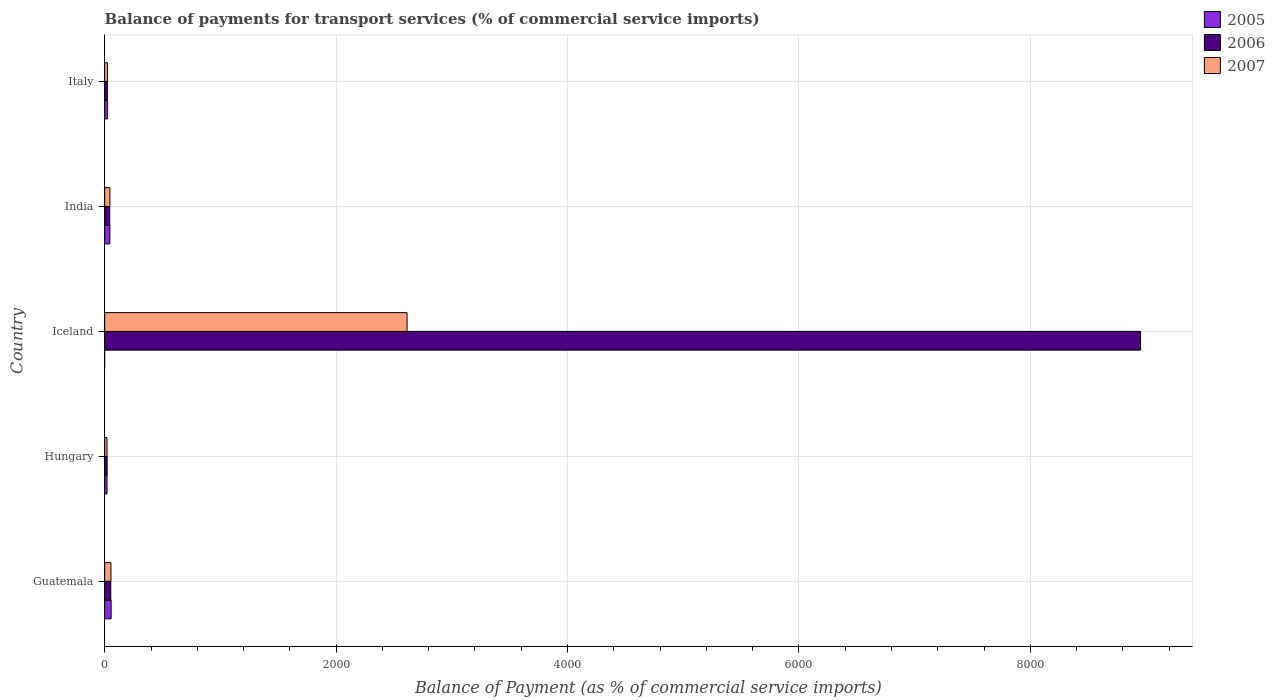How many different coloured bars are there?
Your answer should be compact. 3. Are the number of bars on each tick of the Y-axis equal?
Ensure brevity in your answer.  No. How many bars are there on the 5th tick from the bottom?
Give a very brief answer. 3. In how many cases, is the number of bars for a given country not equal to the number of legend labels?
Give a very brief answer. 1. What is the balance of payments for transport services in 2007 in Italy?
Provide a short and direct response. 23.34. Across all countries, what is the maximum balance of payments for transport services in 2006?
Offer a very short reply. 8952.73. Across all countries, what is the minimum balance of payments for transport services in 2006?
Your answer should be compact. 21.15. What is the total balance of payments for transport services in 2006 in the graph?
Provide a short and direct response. 9093.1. What is the difference between the balance of payments for transport services in 2006 in India and that in Italy?
Make the answer very short. 19.88. What is the difference between the balance of payments for transport services in 2006 in Guatemala and the balance of payments for transport services in 2005 in Iceland?
Provide a succinct answer. 52.41. What is the average balance of payments for transport services in 2006 per country?
Offer a very short reply. 1818.62. What is the difference between the balance of payments for transport services in 2007 and balance of payments for transport services in 2006 in India?
Your answer should be very brief. 1.48. What is the ratio of the balance of payments for transport services in 2006 in Iceland to that in India?
Keep it short and to the point. 206.53. What is the difference between the highest and the second highest balance of payments for transport services in 2005?
Keep it short and to the point. 10.79. What is the difference between the highest and the lowest balance of payments for transport services in 2007?
Your response must be concise. 2593.2. Is it the case that in every country, the sum of the balance of payments for transport services in 2006 and balance of payments for transport services in 2005 is greater than the balance of payments for transport services in 2007?
Provide a succinct answer. Yes. Are all the bars in the graph horizontal?
Your answer should be compact. Yes. How many countries are there in the graph?
Ensure brevity in your answer.  5. Where does the legend appear in the graph?
Provide a succinct answer. Top right. How are the legend labels stacked?
Provide a short and direct response. Vertical. What is the title of the graph?
Your response must be concise. Balance of payments for transport services (% of commercial service imports). Does "1997" appear as one of the legend labels in the graph?
Offer a very short reply. No. What is the label or title of the X-axis?
Ensure brevity in your answer.  Balance of Payment (as % of commercial service imports). What is the label or title of the Y-axis?
Your answer should be very brief. Country. What is the Balance of Payment (as % of commercial service imports) of 2005 in Guatemala?
Make the answer very short. 55.52. What is the Balance of Payment (as % of commercial service imports) in 2006 in Guatemala?
Keep it short and to the point. 52.41. What is the Balance of Payment (as % of commercial service imports) in 2007 in Guatemala?
Your answer should be very brief. 53.64. What is the Balance of Payment (as % of commercial service imports) in 2005 in Hungary?
Offer a terse response. 19.94. What is the Balance of Payment (as % of commercial service imports) of 2006 in Hungary?
Keep it short and to the point. 21.15. What is the Balance of Payment (as % of commercial service imports) in 2007 in Hungary?
Offer a terse response. 20.06. What is the Balance of Payment (as % of commercial service imports) of 2006 in Iceland?
Keep it short and to the point. 8952.73. What is the Balance of Payment (as % of commercial service imports) in 2007 in Iceland?
Your response must be concise. 2613.27. What is the Balance of Payment (as % of commercial service imports) of 2005 in India?
Keep it short and to the point. 44.73. What is the Balance of Payment (as % of commercial service imports) of 2006 in India?
Provide a short and direct response. 43.35. What is the Balance of Payment (as % of commercial service imports) in 2007 in India?
Ensure brevity in your answer.  44.82. What is the Balance of Payment (as % of commercial service imports) in 2005 in Italy?
Give a very brief answer. 24.75. What is the Balance of Payment (as % of commercial service imports) in 2006 in Italy?
Make the answer very short. 23.47. What is the Balance of Payment (as % of commercial service imports) of 2007 in Italy?
Make the answer very short. 23.34. Across all countries, what is the maximum Balance of Payment (as % of commercial service imports) of 2005?
Offer a terse response. 55.52. Across all countries, what is the maximum Balance of Payment (as % of commercial service imports) of 2006?
Keep it short and to the point. 8952.73. Across all countries, what is the maximum Balance of Payment (as % of commercial service imports) in 2007?
Your answer should be very brief. 2613.27. Across all countries, what is the minimum Balance of Payment (as % of commercial service imports) in 2006?
Your answer should be compact. 21.15. Across all countries, what is the minimum Balance of Payment (as % of commercial service imports) in 2007?
Provide a succinct answer. 20.06. What is the total Balance of Payment (as % of commercial service imports) of 2005 in the graph?
Provide a succinct answer. 144.93. What is the total Balance of Payment (as % of commercial service imports) of 2006 in the graph?
Keep it short and to the point. 9093.1. What is the total Balance of Payment (as % of commercial service imports) of 2007 in the graph?
Offer a very short reply. 2755.13. What is the difference between the Balance of Payment (as % of commercial service imports) of 2005 in Guatemala and that in Hungary?
Offer a terse response. 35.58. What is the difference between the Balance of Payment (as % of commercial service imports) of 2006 in Guatemala and that in Hungary?
Offer a very short reply. 31.26. What is the difference between the Balance of Payment (as % of commercial service imports) of 2007 in Guatemala and that in Hungary?
Ensure brevity in your answer.  33.58. What is the difference between the Balance of Payment (as % of commercial service imports) of 2006 in Guatemala and that in Iceland?
Offer a very short reply. -8900.32. What is the difference between the Balance of Payment (as % of commercial service imports) in 2007 in Guatemala and that in Iceland?
Provide a succinct answer. -2559.62. What is the difference between the Balance of Payment (as % of commercial service imports) in 2005 in Guatemala and that in India?
Offer a terse response. 10.79. What is the difference between the Balance of Payment (as % of commercial service imports) of 2006 in Guatemala and that in India?
Give a very brief answer. 9.06. What is the difference between the Balance of Payment (as % of commercial service imports) in 2007 in Guatemala and that in India?
Make the answer very short. 8.82. What is the difference between the Balance of Payment (as % of commercial service imports) of 2005 in Guatemala and that in Italy?
Ensure brevity in your answer.  30.77. What is the difference between the Balance of Payment (as % of commercial service imports) in 2006 in Guatemala and that in Italy?
Ensure brevity in your answer.  28.94. What is the difference between the Balance of Payment (as % of commercial service imports) in 2007 in Guatemala and that in Italy?
Make the answer very short. 30.31. What is the difference between the Balance of Payment (as % of commercial service imports) of 2006 in Hungary and that in Iceland?
Offer a terse response. -8931.58. What is the difference between the Balance of Payment (as % of commercial service imports) in 2007 in Hungary and that in Iceland?
Keep it short and to the point. -2593.2. What is the difference between the Balance of Payment (as % of commercial service imports) in 2005 in Hungary and that in India?
Your response must be concise. -24.79. What is the difference between the Balance of Payment (as % of commercial service imports) in 2006 in Hungary and that in India?
Provide a succinct answer. -22.2. What is the difference between the Balance of Payment (as % of commercial service imports) in 2007 in Hungary and that in India?
Ensure brevity in your answer.  -24.76. What is the difference between the Balance of Payment (as % of commercial service imports) of 2005 in Hungary and that in Italy?
Your answer should be very brief. -4.81. What is the difference between the Balance of Payment (as % of commercial service imports) in 2006 in Hungary and that in Italy?
Ensure brevity in your answer.  -2.32. What is the difference between the Balance of Payment (as % of commercial service imports) of 2007 in Hungary and that in Italy?
Provide a succinct answer. -3.27. What is the difference between the Balance of Payment (as % of commercial service imports) in 2006 in Iceland and that in India?
Ensure brevity in your answer.  8909.38. What is the difference between the Balance of Payment (as % of commercial service imports) of 2007 in Iceland and that in India?
Your answer should be very brief. 2568.44. What is the difference between the Balance of Payment (as % of commercial service imports) in 2006 in Iceland and that in Italy?
Provide a short and direct response. 8929.26. What is the difference between the Balance of Payment (as % of commercial service imports) of 2007 in Iceland and that in Italy?
Your response must be concise. 2589.93. What is the difference between the Balance of Payment (as % of commercial service imports) in 2005 in India and that in Italy?
Keep it short and to the point. 19.98. What is the difference between the Balance of Payment (as % of commercial service imports) of 2006 in India and that in Italy?
Offer a very short reply. 19.88. What is the difference between the Balance of Payment (as % of commercial service imports) in 2007 in India and that in Italy?
Provide a succinct answer. 21.49. What is the difference between the Balance of Payment (as % of commercial service imports) in 2005 in Guatemala and the Balance of Payment (as % of commercial service imports) in 2006 in Hungary?
Provide a short and direct response. 34.37. What is the difference between the Balance of Payment (as % of commercial service imports) in 2005 in Guatemala and the Balance of Payment (as % of commercial service imports) in 2007 in Hungary?
Your response must be concise. 35.45. What is the difference between the Balance of Payment (as % of commercial service imports) in 2006 in Guatemala and the Balance of Payment (as % of commercial service imports) in 2007 in Hungary?
Ensure brevity in your answer.  32.35. What is the difference between the Balance of Payment (as % of commercial service imports) in 2005 in Guatemala and the Balance of Payment (as % of commercial service imports) in 2006 in Iceland?
Offer a terse response. -8897.21. What is the difference between the Balance of Payment (as % of commercial service imports) of 2005 in Guatemala and the Balance of Payment (as % of commercial service imports) of 2007 in Iceland?
Keep it short and to the point. -2557.75. What is the difference between the Balance of Payment (as % of commercial service imports) in 2006 in Guatemala and the Balance of Payment (as % of commercial service imports) in 2007 in Iceland?
Your answer should be very brief. -2560.86. What is the difference between the Balance of Payment (as % of commercial service imports) of 2005 in Guatemala and the Balance of Payment (as % of commercial service imports) of 2006 in India?
Provide a short and direct response. 12.17. What is the difference between the Balance of Payment (as % of commercial service imports) in 2005 in Guatemala and the Balance of Payment (as % of commercial service imports) in 2007 in India?
Your answer should be very brief. 10.69. What is the difference between the Balance of Payment (as % of commercial service imports) of 2006 in Guatemala and the Balance of Payment (as % of commercial service imports) of 2007 in India?
Give a very brief answer. 7.59. What is the difference between the Balance of Payment (as % of commercial service imports) in 2005 in Guatemala and the Balance of Payment (as % of commercial service imports) in 2006 in Italy?
Your answer should be compact. 32.05. What is the difference between the Balance of Payment (as % of commercial service imports) in 2005 in Guatemala and the Balance of Payment (as % of commercial service imports) in 2007 in Italy?
Ensure brevity in your answer.  32.18. What is the difference between the Balance of Payment (as % of commercial service imports) in 2006 in Guatemala and the Balance of Payment (as % of commercial service imports) in 2007 in Italy?
Provide a short and direct response. 29.07. What is the difference between the Balance of Payment (as % of commercial service imports) of 2005 in Hungary and the Balance of Payment (as % of commercial service imports) of 2006 in Iceland?
Make the answer very short. -8932.79. What is the difference between the Balance of Payment (as % of commercial service imports) in 2005 in Hungary and the Balance of Payment (as % of commercial service imports) in 2007 in Iceland?
Your response must be concise. -2593.33. What is the difference between the Balance of Payment (as % of commercial service imports) of 2006 in Hungary and the Balance of Payment (as % of commercial service imports) of 2007 in Iceland?
Offer a very short reply. -2592.12. What is the difference between the Balance of Payment (as % of commercial service imports) in 2005 in Hungary and the Balance of Payment (as % of commercial service imports) in 2006 in India?
Ensure brevity in your answer.  -23.41. What is the difference between the Balance of Payment (as % of commercial service imports) in 2005 in Hungary and the Balance of Payment (as % of commercial service imports) in 2007 in India?
Offer a terse response. -24.88. What is the difference between the Balance of Payment (as % of commercial service imports) in 2006 in Hungary and the Balance of Payment (as % of commercial service imports) in 2007 in India?
Provide a succinct answer. -23.68. What is the difference between the Balance of Payment (as % of commercial service imports) in 2005 in Hungary and the Balance of Payment (as % of commercial service imports) in 2006 in Italy?
Give a very brief answer. -3.53. What is the difference between the Balance of Payment (as % of commercial service imports) of 2005 in Hungary and the Balance of Payment (as % of commercial service imports) of 2007 in Italy?
Keep it short and to the point. -3.4. What is the difference between the Balance of Payment (as % of commercial service imports) of 2006 in Hungary and the Balance of Payment (as % of commercial service imports) of 2007 in Italy?
Your answer should be very brief. -2.19. What is the difference between the Balance of Payment (as % of commercial service imports) of 2006 in Iceland and the Balance of Payment (as % of commercial service imports) of 2007 in India?
Offer a very short reply. 8907.91. What is the difference between the Balance of Payment (as % of commercial service imports) of 2006 in Iceland and the Balance of Payment (as % of commercial service imports) of 2007 in Italy?
Make the answer very short. 8929.39. What is the difference between the Balance of Payment (as % of commercial service imports) of 2005 in India and the Balance of Payment (as % of commercial service imports) of 2006 in Italy?
Your answer should be compact. 21.26. What is the difference between the Balance of Payment (as % of commercial service imports) in 2005 in India and the Balance of Payment (as % of commercial service imports) in 2007 in Italy?
Provide a short and direct response. 21.39. What is the difference between the Balance of Payment (as % of commercial service imports) in 2006 in India and the Balance of Payment (as % of commercial service imports) in 2007 in Italy?
Give a very brief answer. 20.01. What is the average Balance of Payment (as % of commercial service imports) of 2005 per country?
Your response must be concise. 28.99. What is the average Balance of Payment (as % of commercial service imports) of 2006 per country?
Your answer should be very brief. 1818.62. What is the average Balance of Payment (as % of commercial service imports) in 2007 per country?
Offer a terse response. 551.03. What is the difference between the Balance of Payment (as % of commercial service imports) in 2005 and Balance of Payment (as % of commercial service imports) in 2006 in Guatemala?
Make the answer very short. 3.11. What is the difference between the Balance of Payment (as % of commercial service imports) in 2005 and Balance of Payment (as % of commercial service imports) in 2007 in Guatemala?
Make the answer very short. 1.87. What is the difference between the Balance of Payment (as % of commercial service imports) of 2006 and Balance of Payment (as % of commercial service imports) of 2007 in Guatemala?
Make the answer very short. -1.24. What is the difference between the Balance of Payment (as % of commercial service imports) of 2005 and Balance of Payment (as % of commercial service imports) of 2006 in Hungary?
Keep it short and to the point. -1.21. What is the difference between the Balance of Payment (as % of commercial service imports) of 2005 and Balance of Payment (as % of commercial service imports) of 2007 in Hungary?
Your answer should be very brief. -0.12. What is the difference between the Balance of Payment (as % of commercial service imports) in 2006 and Balance of Payment (as % of commercial service imports) in 2007 in Hungary?
Your response must be concise. 1.08. What is the difference between the Balance of Payment (as % of commercial service imports) in 2006 and Balance of Payment (as % of commercial service imports) in 2007 in Iceland?
Keep it short and to the point. 6339.46. What is the difference between the Balance of Payment (as % of commercial service imports) of 2005 and Balance of Payment (as % of commercial service imports) of 2006 in India?
Provide a succinct answer. 1.38. What is the difference between the Balance of Payment (as % of commercial service imports) in 2005 and Balance of Payment (as % of commercial service imports) in 2007 in India?
Provide a succinct answer. -0.1. What is the difference between the Balance of Payment (as % of commercial service imports) of 2006 and Balance of Payment (as % of commercial service imports) of 2007 in India?
Keep it short and to the point. -1.48. What is the difference between the Balance of Payment (as % of commercial service imports) of 2005 and Balance of Payment (as % of commercial service imports) of 2006 in Italy?
Make the answer very short. 1.28. What is the difference between the Balance of Payment (as % of commercial service imports) of 2005 and Balance of Payment (as % of commercial service imports) of 2007 in Italy?
Your answer should be very brief. 1.41. What is the difference between the Balance of Payment (as % of commercial service imports) in 2006 and Balance of Payment (as % of commercial service imports) in 2007 in Italy?
Give a very brief answer. 0.13. What is the ratio of the Balance of Payment (as % of commercial service imports) of 2005 in Guatemala to that in Hungary?
Keep it short and to the point. 2.78. What is the ratio of the Balance of Payment (as % of commercial service imports) in 2006 in Guatemala to that in Hungary?
Provide a succinct answer. 2.48. What is the ratio of the Balance of Payment (as % of commercial service imports) in 2007 in Guatemala to that in Hungary?
Give a very brief answer. 2.67. What is the ratio of the Balance of Payment (as % of commercial service imports) in 2006 in Guatemala to that in Iceland?
Give a very brief answer. 0.01. What is the ratio of the Balance of Payment (as % of commercial service imports) of 2007 in Guatemala to that in Iceland?
Your answer should be compact. 0.02. What is the ratio of the Balance of Payment (as % of commercial service imports) of 2005 in Guatemala to that in India?
Give a very brief answer. 1.24. What is the ratio of the Balance of Payment (as % of commercial service imports) of 2006 in Guatemala to that in India?
Make the answer very short. 1.21. What is the ratio of the Balance of Payment (as % of commercial service imports) of 2007 in Guatemala to that in India?
Your response must be concise. 1.2. What is the ratio of the Balance of Payment (as % of commercial service imports) of 2005 in Guatemala to that in Italy?
Offer a very short reply. 2.24. What is the ratio of the Balance of Payment (as % of commercial service imports) in 2006 in Guatemala to that in Italy?
Ensure brevity in your answer.  2.23. What is the ratio of the Balance of Payment (as % of commercial service imports) of 2007 in Guatemala to that in Italy?
Provide a succinct answer. 2.3. What is the ratio of the Balance of Payment (as % of commercial service imports) in 2006 in Hungary to that in Iceland?
Your answer should be very brief. 0. What is the ratio of the Balance of Payment (as % of commercial service imports) in 2007 in Hungary to that in Iceland?
Ensure brevity in your answer.  0.01. What is the ratio of the Balance of Payment (as % of commercial service imports) in 2005 in Hungary to that in India?
Make the answer very short. 0.45. What is the ratio of the Balance of Payment (as % of commercial service imports) in 2006 in Hungary to that in India?
Offer a terse response. 0.49. What is the ratio of the Balance of Payment (as % of commercial service imports) in 2007 in Hungary to that in India?
Keep it short and to the point. 0.45. What is the ratio of the Balance of Payment (as % of commercial service imports) in 2005 in Hungary to that in Italy?
Make the answer very short. 0.81. What is the ratio of the Balance of Payment (as % of commercial service imports) of 2006 in Hungary to that in Italy?
Keep it short and to the point. 0.9. What is the ratio of the Balance of Payment (as % of commercial service imports) of 2007 in Hungary to that in Italy?
Give a very brief answer. 0.86. What is the ratio of the Balance of Payment (as % of commercial service imports) of 2006 in Iceland to that in India?
Provide a short and direct response. 206.53. What is the ratio of the Balance of Payment (as % of commercial service imports) in 2007 in Iceland to that in India?
Your response must be concise. 58.3. What is the ratio of the Balance of Payment (as % of commercial service imports) of 2006 in Iceland to that in Italy?
Provide a succinct answer. 381.47. What is the ratio of the Balance of Payment (as % of commercial service imports) in 2007 in Iceland to that in Italy?
Provide a short and direct response. 111.99. What is the ratio of the Balance of Payment (as % of commercial service imports) of 2005 in India to that in Italy?
Provide a short and direct response. 1.81. What is the ratio of the Balance of Payment (as % of commercial service imports) of 2006 in India to that in Italy?
Make the answer very short. 1.85. What is the ratio of the Balance of Payment (as % of commercial service imports) in 2007 in India to that in Italy?
Your answer should be compact. 1.92. What is the difference between the highest and the second highest Balance of Payment (as % of commercial service imports) in 2005?
Provide a short and direct response. 10.79. What is the difference between the highest and the second highest Balance of Payment (as % of commercial service imports) of 2006?
Provide a succinct answer. 8900.32. What is the difference between the highest and the second highest Balance of Payment (as % of commercial service imports) of 2007?
Offer a very short reply. 2559.62. What is the difference between the highest and the lowest Balance of Payment (as % of commercial service imports) in 2005?
Keep it short and to the point. 55.52. What is the difference between the highest and the lowest Balance of Payment (as % of commercial service imports) of 2006?
Make the answer very short. 8931.58. What is the difference between the highest and the lowest Balance of Payment (as % of commercial service imports) in 2007?
Provide a short and direct response. 2593.2. 